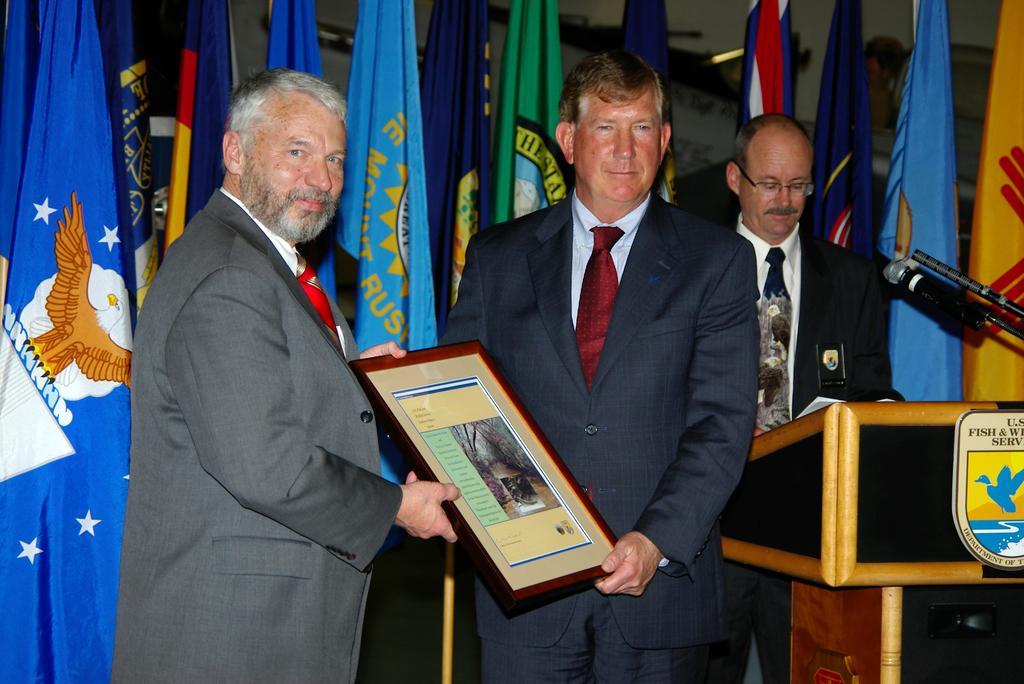Could you give a brief overview of what you see in this image? In the given image i can see a people,award,mike,flags and desk. 